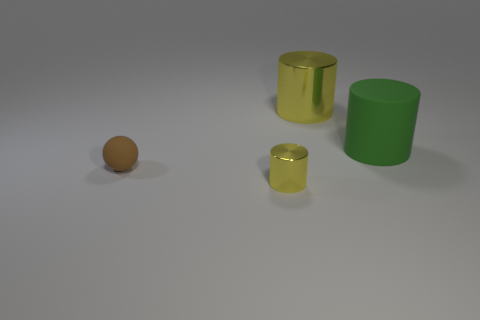Subtract all green spheres. How many yellow cylinders are left? 2 Add 4 large green cylinders. How many objects exist? 8 Subtract 1 cylinders. How many cylinders are left? 2 Subtract all balls. How many objects are left? 3 Subtract 1 brown balls. How many objects are left? 3 Subtract all large gray matte things. Subtract all green cylinders. How many objects are left? 3 Add 1 balls. How many balls are left? 2 Add 1 large green objects. How many large green objects exist? 2 